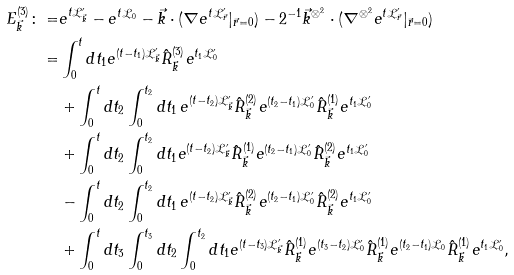Convert formula to latex. <formula><loc_0><loc_0><loc_500><loc_500>E _ { \vec { k } } ^ { ( 3 ) } \colon = & e ^ { t \mathcal { L } _ { \vec { k } } ^ { \prime } } - e ^ { t \mathcal { L } _ { 0 } } - \vec { k } \cdot ( \nabla e ^ { t \mathcal { L } _ { \vec { r } } ^ { \prime } } | _ { \vec { r } = 0 } ) - 2 ^ { - 1 } \vec { k } ^ { \otimes ^ { 2 } } \cdot ( \nabla ^ { \otimes ^ { 2 } } e ^ { t \mathcal { L } _ { \vec { r } } ^ { \prime } } | _ { \vec { r } = 0 } ) \\ = & \int _ { 0 } ^ { t } d t _ { 1 } e ^ { ( t - t _ { 1 } ) \mathcal { L } _ { \vec { k } } ^ { \prime } } \hat { R } _ { \vec { k } } ^ { ( 3 ) } e ^ { t _ { 1 } \mathcal { L } _ { 0 } ^ { \prime } } \\ & + \int _ { 0 } ^ { t } d t _ { 2 } \int _ { 0 } ^ { t _ { 2 } } d t _ { 1 } \, e ^ { ( t - t _ { 2 } ) \mathcal { L } _ { \vec { k } } ^ { \prime } } \hat { R } _ { \vec { k } } ^ { ( 2 ) } e ^ { ( t _ { 2 } - t _ { 1 } ) \mathcal { L } _ { 0 } ^ { \prime } } \hat { R } _ { \vec { k } } ^ { ( 1 ) } e ^ { t _ { 1 } \mathcal { L } _ { 0 } ^ { \prime } } \\ & + \int _ { 0 } ^ { t } d t _ { 2 } \int _ { 0 } ^ { t _ { 2 } } d t _ { 1 } e ^ { ( t - t _ { 2 } ) \mathcal { L } _ { \vec { k } } ^ { \prime } } \hat { R } _ { \vec { k } } ^ { ( 1 ) } e ^ { ( t _ { 2 } - t _ { 1 } ) \mathcal { L } _ { 0 } ^ { \prime } } \hat { R } _ { \vec { k } } ^ { ( 2 ) } e ^ { t _ { 1 } \mathcal { L } _ { 0 } ^ { \prime } } \\ & - \int _ { 0 } ^ { t } d t _ { 2 } \int _ { 0 } ^ { t _ { 2 } } d t _ { 1 } \, e ^ { ( t - t _ { 2 } ) \mathcal { L } _ { \vec { k } } ^ { \prime } } \hat { R } _ { \vec { k } } ^ { ( 2 ) } e ^ { ( t _ { 2 } - t _ { 1 } ) \mathcal { L } _ { 0 } ^ { \prime } } \hat { R } _ { \vec { k } } ^ { ( 2 ) } e ^ { t _ { 1 } \mathcal { L } _ { 0 } ^ { \prime } } \\ & + \int _ { 0 } ^ { t } d t _ { 3 } \int _ { 0 } ^ { t _ { 3 } } d t _ { 2 } \int _ { 0 } ^ { t _ { 2 } } d t _ { 1 } e ^ { ( t - t _ { 3 } ) \mathcal { L } _ { \vec { k } } ^ { \prime } } \hat { R } _ { \vec { k } } ^ { ( 1 ) } e ^ { ( t _ { 3 } - t _ { 2 } ) \mathcal { L } _ { 0 } ^ { \prime } } \hat { R } _ { \vec { k } } ^ { ( 1 ) } e ^ { ( t _ { 2 } - t _ { 1 } ) \mathcal { L } _ { 0 } } \hat { R } _ { \vec { k } } ^ { ( 1 ) } e ^ { t _ { 1 } \mathcal { L } _ { 0 } ^ { \prime } } ,</formula> 